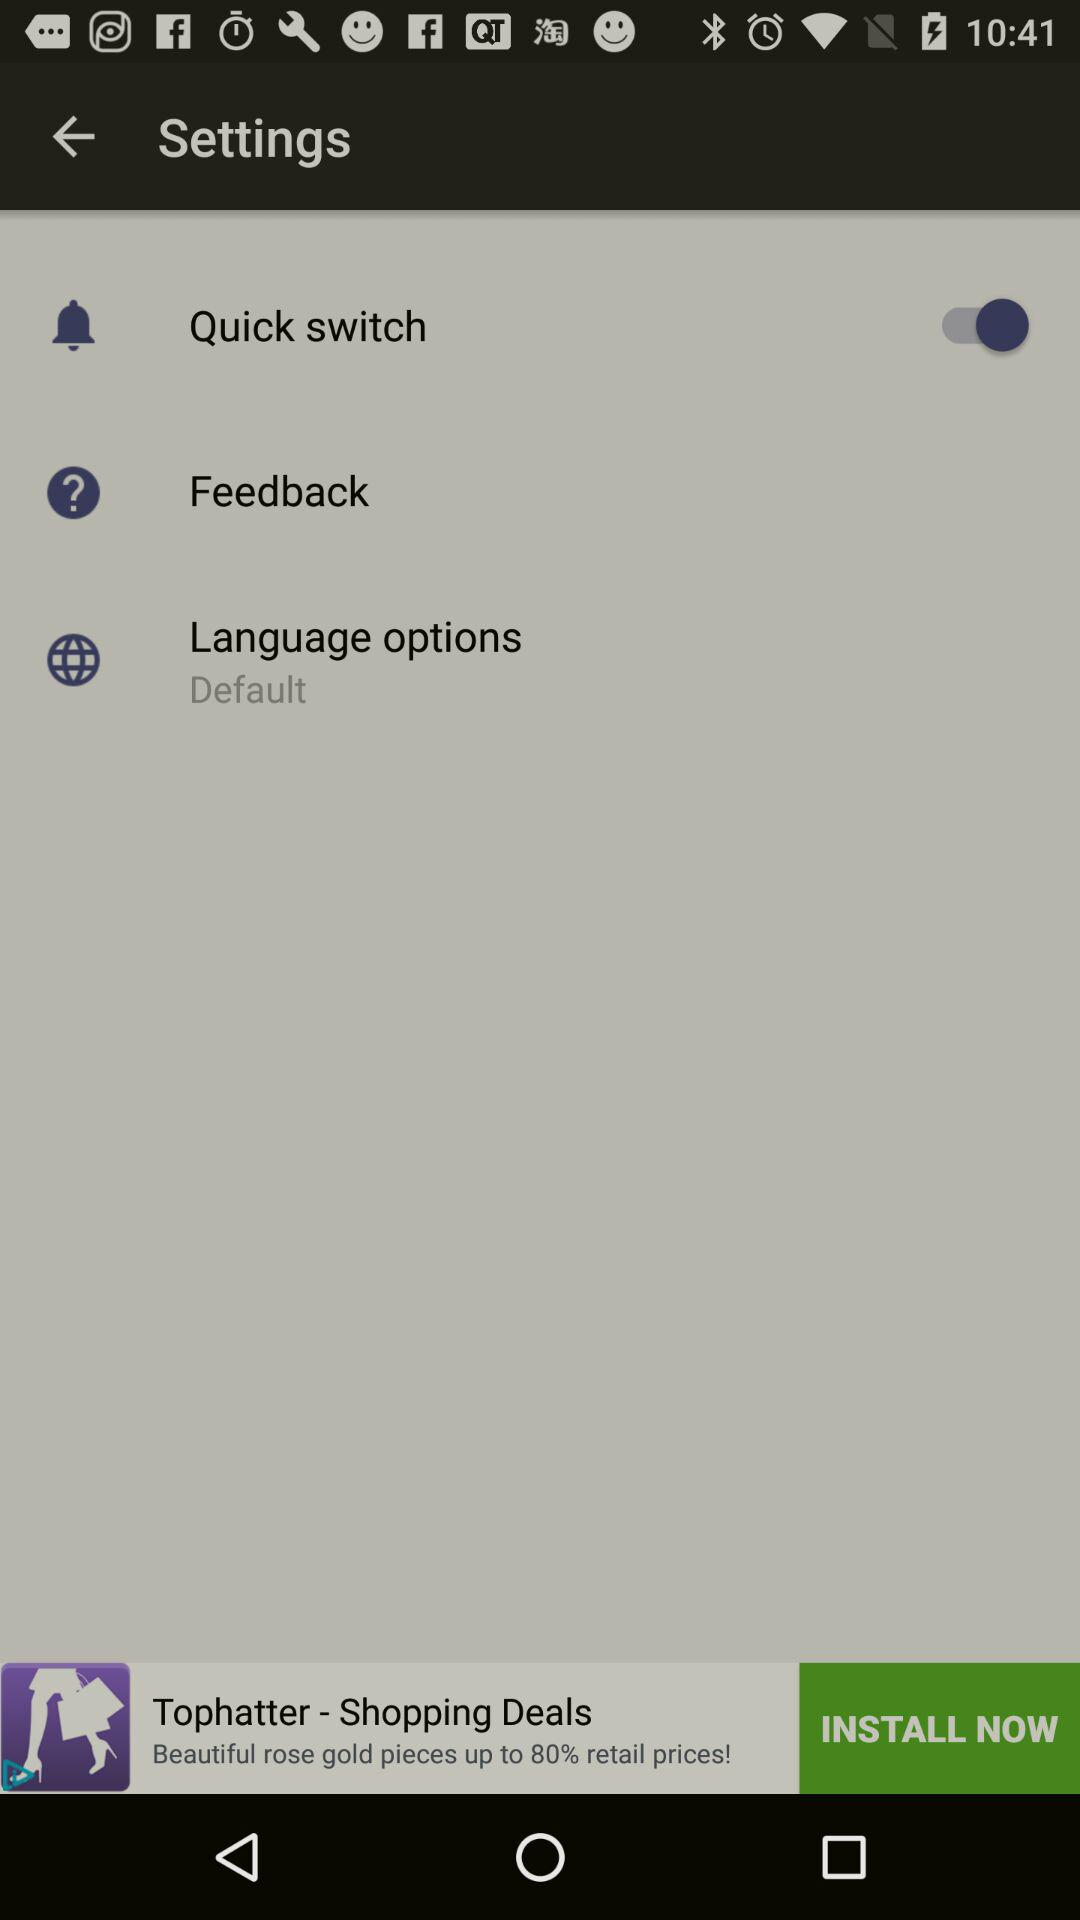What is the status of Quick switch? The status is on. 